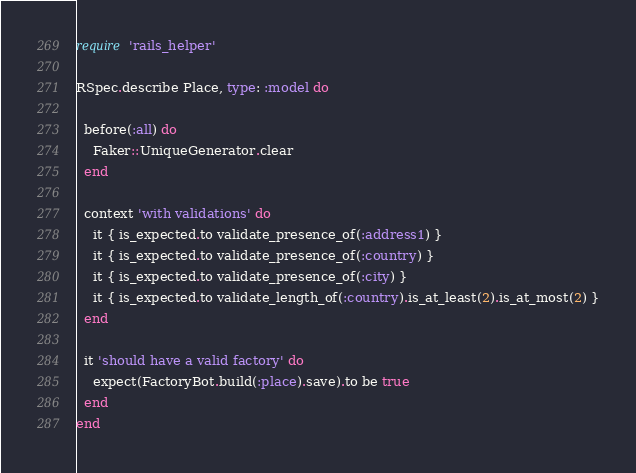Convert code to text. <code><loc_0><loc_0><loc_500><loc_500><_Ruby_>require 'rails_helper'

RSpec.describe Place, type: :model do

  before(:all) do
    Faker::UniqueGenerator.clear
  end

  context 'with validations' do
    it { is_expected.to validate_presence_of(:address1) }
    it { is_expected.to validate_presence_of(:country) }
    it { is_expected.to validate_presence_of(:city) }
    it { is_expected.to validate_length_of(:country).is_at_least(2).is_at_most(2) }
  end

  it 'should have a valid factory' do
    expect(FactoryBot.build(:place).save).to be true
  end
end</code> 